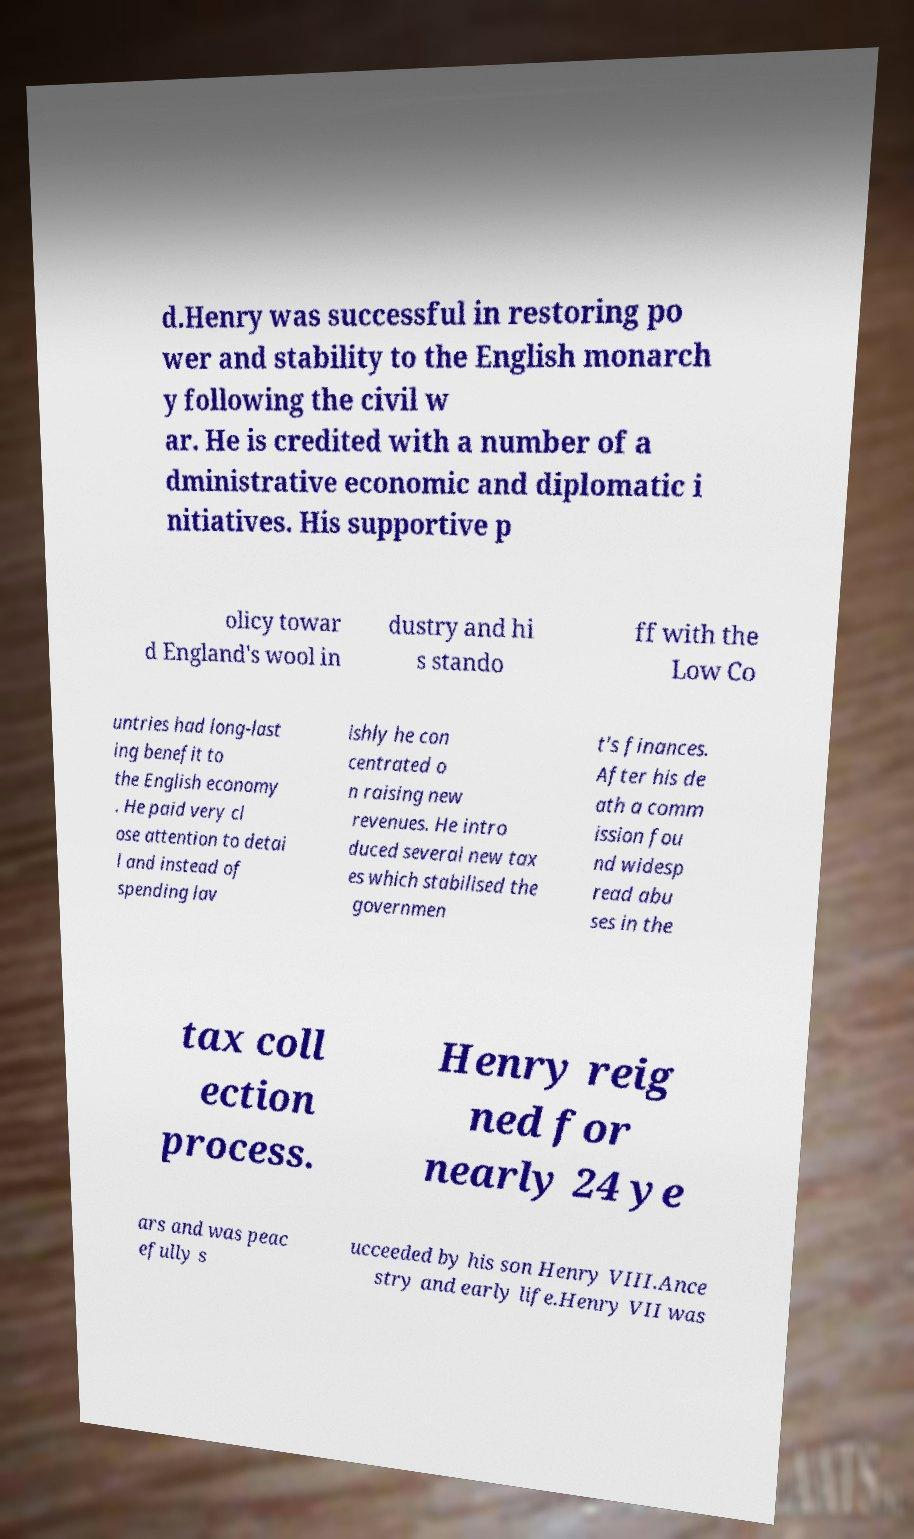Could you extract and type out the text from this image? d.Henry was successful in restoring po wer and stability to the English monarch y following the civil w ar. He is credited with a number of a dministrative economic and diplomatic i nitiatives. His supportive p olicy towar d England's wool in dustry and hi s stando ff with the Low Co untries had long-last ing benefit to the English economy . He paid very cl ose attention to detai l and instead of spending lav ishly he con centrated o n raising new revenues. He intro duced several new tax es which stabilised the governmen t's finances. After his de ath a comm ission fou nd widesp read abu ses in the tax coll ection process. Henry reig ned for nearly 24 ye ars and was peac efully s ucceeded by his son Henry VIII.Ance stry and early life.Henry VII was 